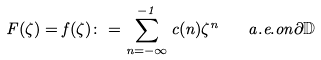Convert formula to latex. <formula><loc_0><loc_0><loc_500><loc_500>F ( \zeta ) = f ( \zeta ) \colon = \sum _ { n = - \infty } ^ { - 1 } c ( n ) \zeta ^ { n } \quad a . e . o n \partial \mathbb { D }</formula> 